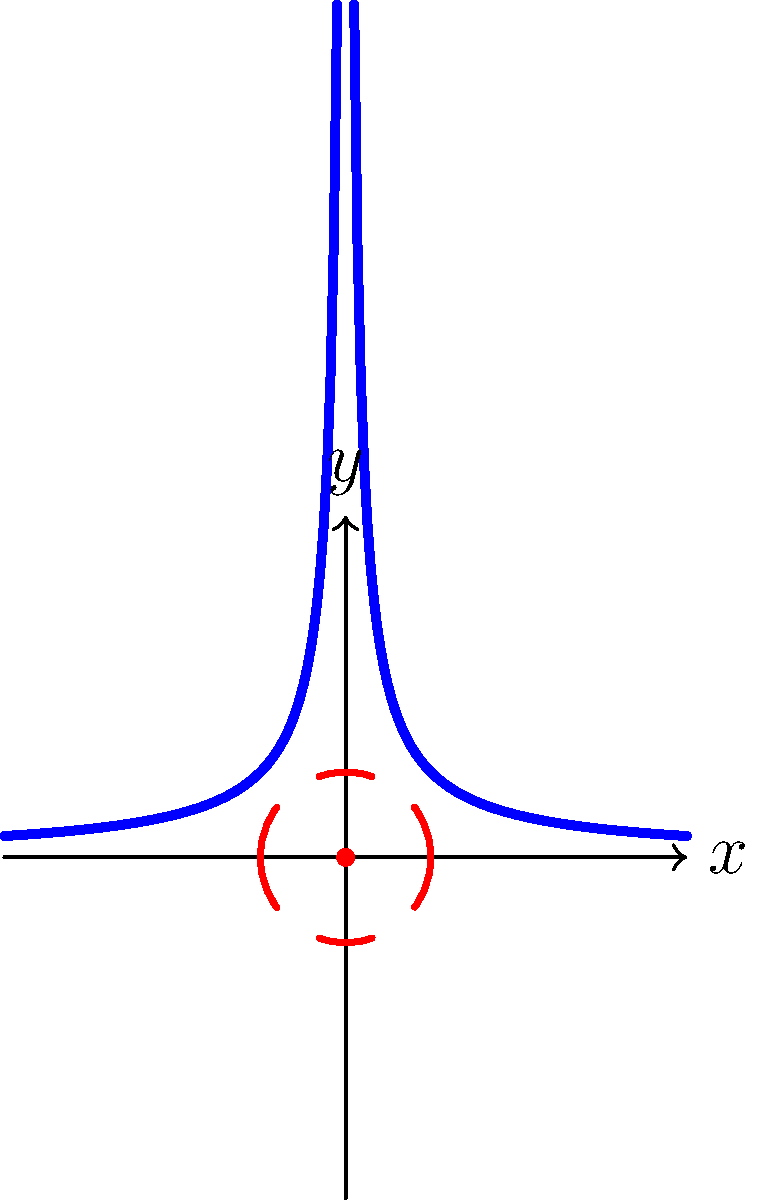In the abstract representation of magnetic field lines around a current-carrying wire, the diagram shows a unique pattern. How does this pattern relate to the Right-Hand Rule, and what artistic elements could be incorporated to enhance its visual impact while maintaining scientific accuracy? To understand this abstract representation and its artistic potential, let's break it down step-by-step:

1. The diagram shows two hyperbolic curves (blue) representing the magnetic field lines around a current-carrying wire.

2. The red dot at the center (0,0) symbolizes the cross-section of the wire, with current flowing perpendicular to the plane.

3. The Right-Hand Rule states that if you align your right thumb with the direction of current flow, your fingers will curl in the direction of the magnetic field lines.

4. In this abstract representation, the hyperbolic curves capture the circular nature of the magnetic field lines when viewed from a side perspective.

5. The dashed red circles hint at the concentric circular pattern of the magnetic field when viewed end-on.

6. To enhance the visual impact while maintaining scientific accuracy:
   a) Use color gradients along the curves to represent field strength.
   b) Incorporate subtle textures or patterns within the curves to suggest motion or energy.
   c) Experiment with line weights to emphasize depth and dimension.
   d) Add abstract elements in the background that complement the curves without distorting the scientific message.
   e) Consider using negative space creatively to highlight the central wire and field lines.

7. The abstraction allows for artistic interpretation while preserving the key scientific principles:
   a) The symmetry of the field lines
   b) The decreasing field strength with distance (represented by curve spacing)
   c) The perpendicular relationship between the wire and field lines

By balancing these scientific principles with artistic elements, one can create a visually striking representation that remains true to the physics of magnetic fields.
Answer: Abstract hyperbolic curves represent side view of circular magnetic field; enhance with color gradients, textures, and creative use of space while maintaining scientific accuracy. 